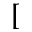Convert formula to latex. <formula><loc_0><loc_0><loc_500><loc_500>[</formula> 